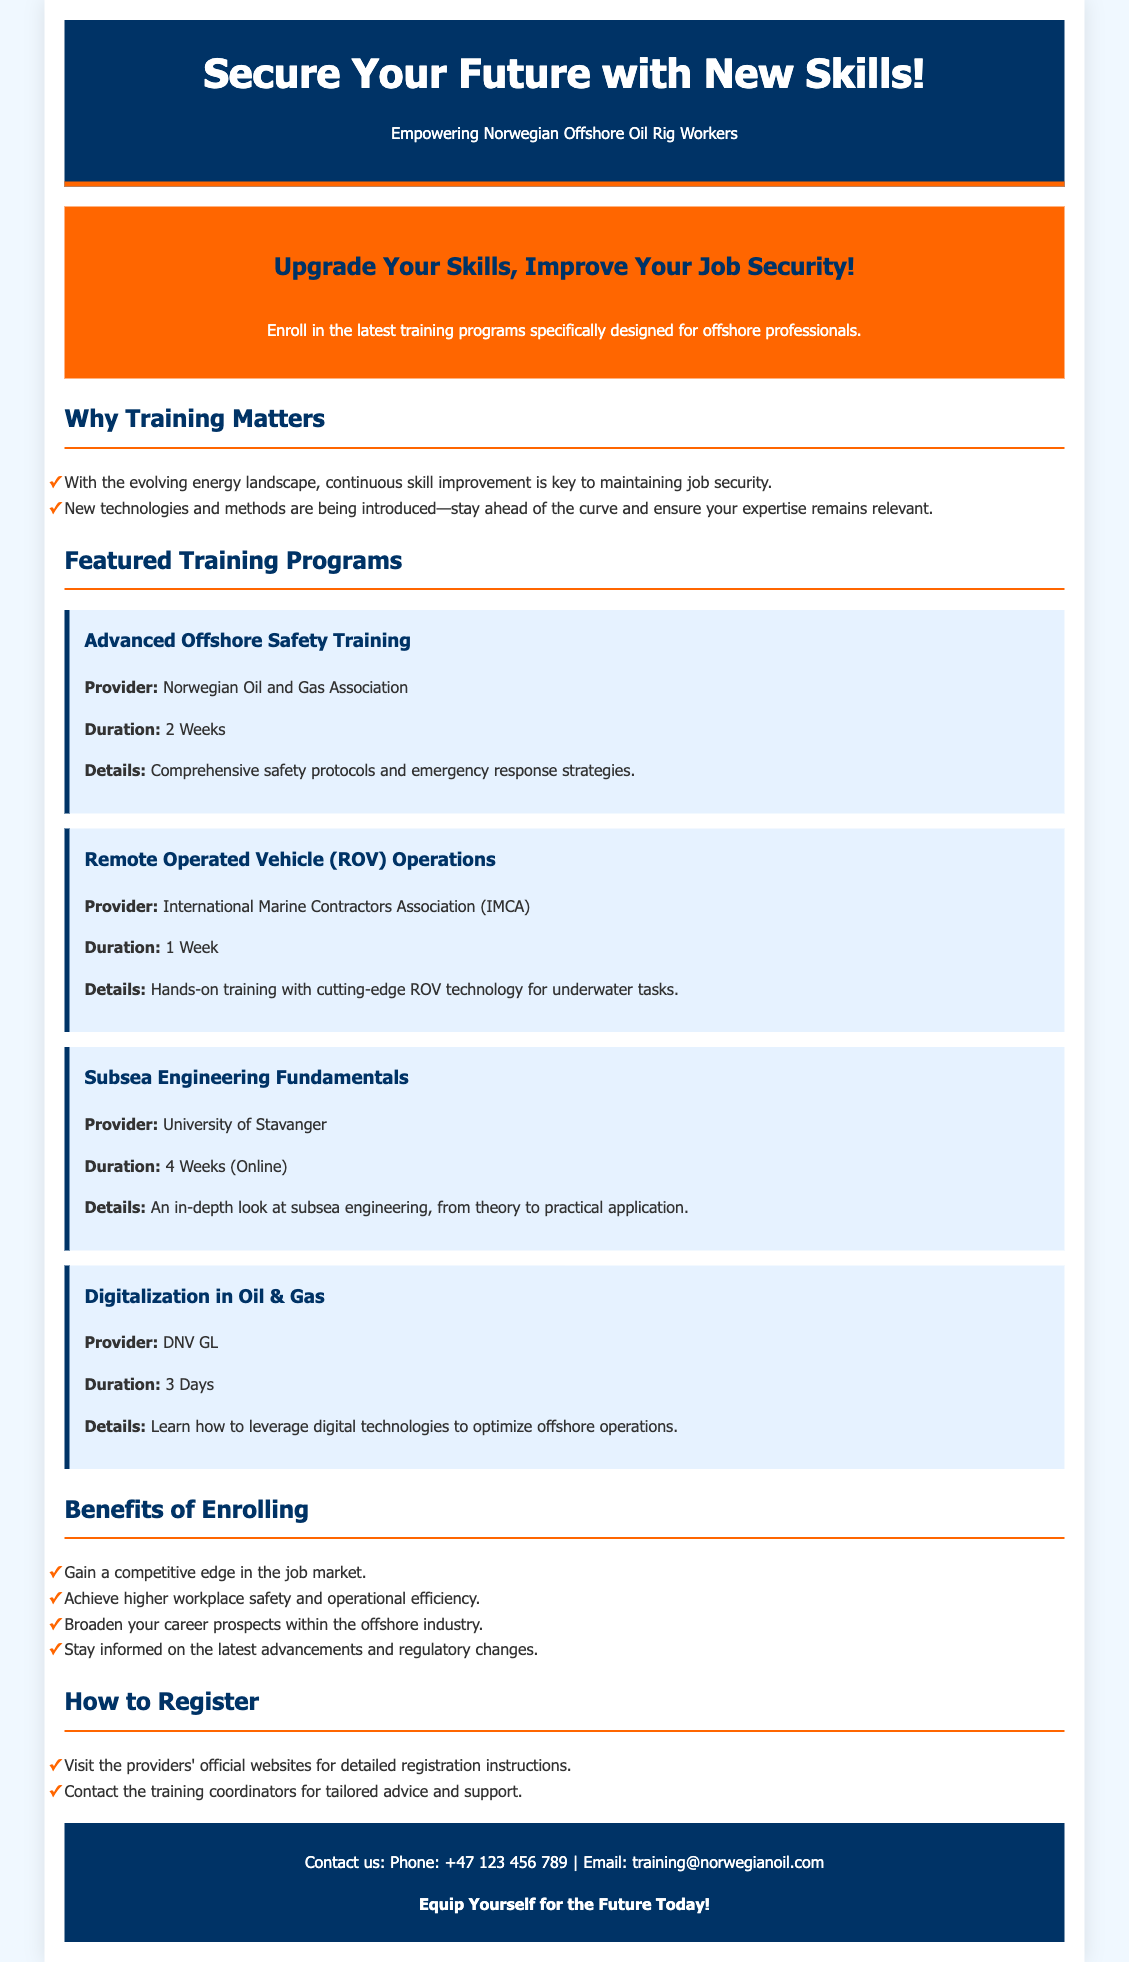What is the title of the flyer? The title of the flyer is prominently displayed at the top.
Answer: Secure Your Future with New Skills! Who is the target audience for the training opportunities? The flyer specifies the intended recipients of the training.
Answer: Norwegian Offshore Oil Rig Workers How long is the Advanced Offshore Safety Training? The duration is mentioned in the course details.
Answer: 2 Weeks Which provider offers the Digitalization in Oil & Gas training? The name of the provider is noted in the respective course details.
Answer: DNV GL What is one benefit of enrolling in the training programs? Benefits are listed in a section dedicated to advantages of the training.
Answer: Gain a competitive edge in the job market How can one register for the training? The section outlines methods to register.
Answer: Visit the providers' official websites What type of training is the ROV Operations course focused on? The course description provides details about the subject matter.
Answer: Hands-on training with cutting-edge ROV technology How long is the Subsea Engineering Fundamentals course? The duration is specified in the course details.
Answer: 4 Weeks (Online) 